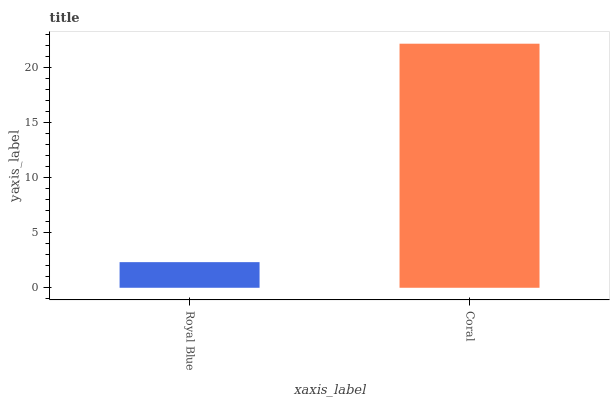Is Royal Blue the minimum?
Answer yes or no. Yes. Is Coral the maximum?
Answer yes or no. Yes. Is Coral the minimum?
Answer yes or no. No. Is Coral greater than Royal Blue?
Answer yes or no. Yes. Is Royal Blue less than Coral?
Answer yes or no. Yes. Is Royal Blue greater than Coral?
Answer yes or no. No. Is Coral less than Royal Blue?
Answer yes or no. No. Is Coral the high median?
Answer yes or no. Yes. Is Royal Blue the low median?
Answer yes or no. Yes. Is Royal Blue the high median?
Answer yes or no. No. Is Coral the low median?
Answer yes or no. No. 